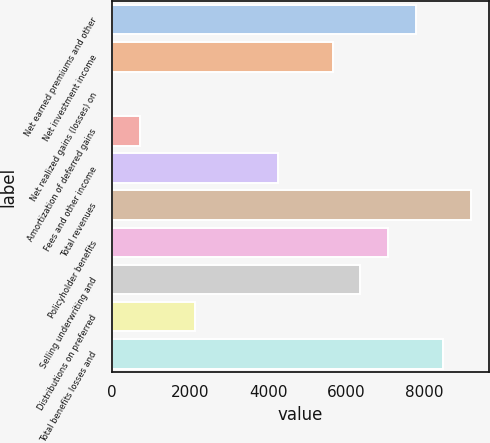<chart> <loc_0><loc_0><loc_500><loc_500><bar_chart><fcel>Net earned premiums and other<fcel>Net investment income<fcel>Net realized gains (losses) on<fcel>Amortization of deferred gains<fcel>Fees and other income<fcel>Total revenues<fcel>Policyholder benefits<fcel>Selling underwriting and<fcel>Distributions on preferred<fcel>Total benefits losses and<nl><fcel>7772.4<fcel>5653.2<fcel>2<fcel>708.4<fcel>4240.4<fcel>9185.2<fcel>7066<fcel>6359.6<fcel>2121.2<fcel>8478.8<nl></chart> 